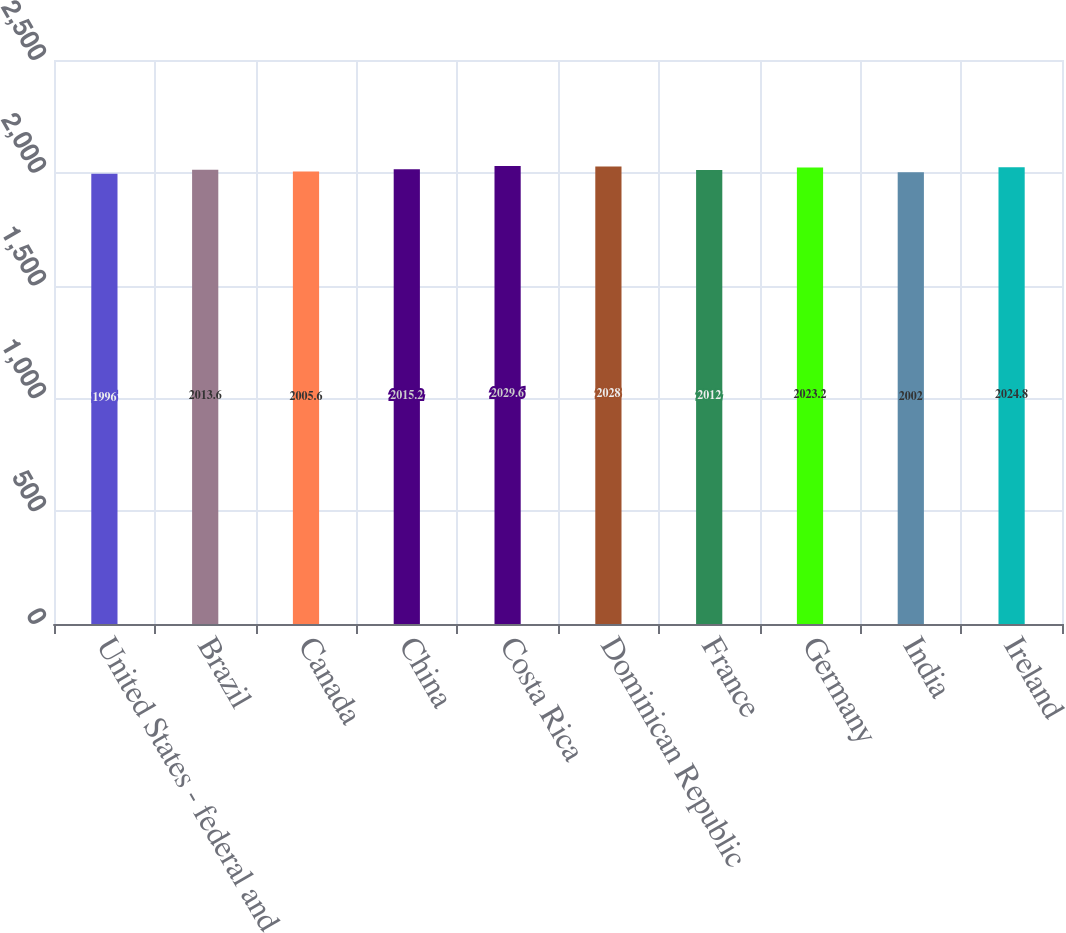Convert chart to OTSL. <chart><loc_0><loc_0><loc_500><loc_500><bar_chart><fcel>United States - federal and<fcel>Brazil<fcel>Canada<fcel>China<fcel>Costa Rica<fcel>Dominican Republic<fcel>France<fcel>Germany<fcel>India<fcel>Ireland<nl><fcel>1996<fcel>2013.6<fcel>2005.6<fcel>2015.2<fcel>2029.6<fcel>2028<fcel>2012<fcel>2023.2<fcel>2002<fcel>2024.8<nl></chart> 